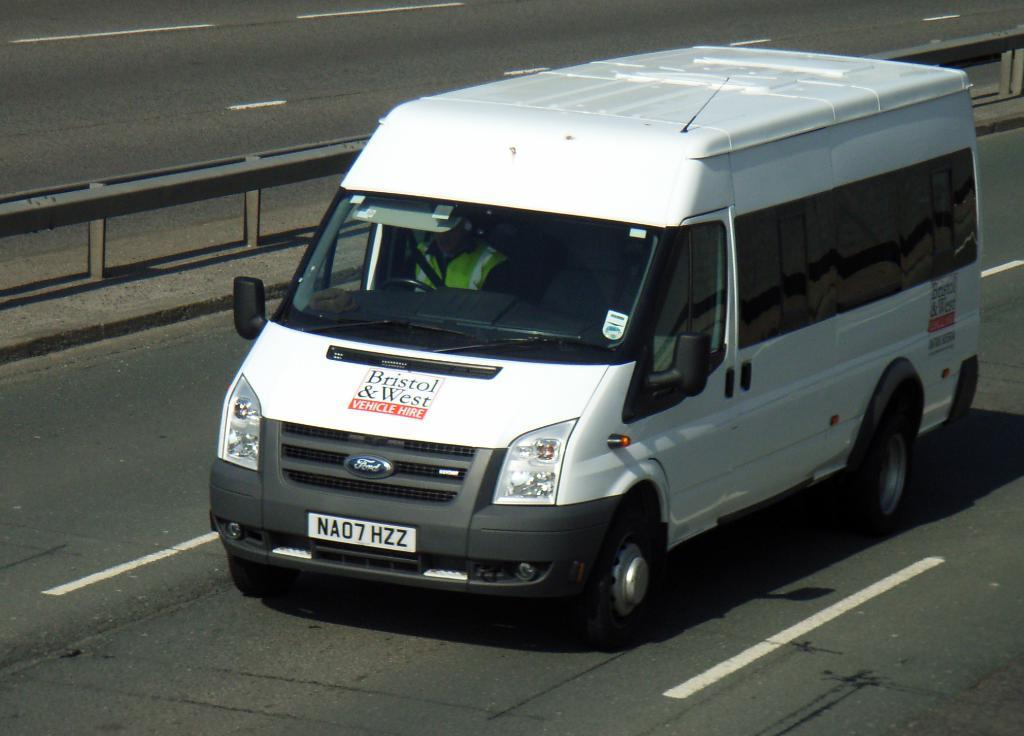<image>
Write a terse but informative summary of the picture. A Bristol & West van was built by the Ford Motor Company. 